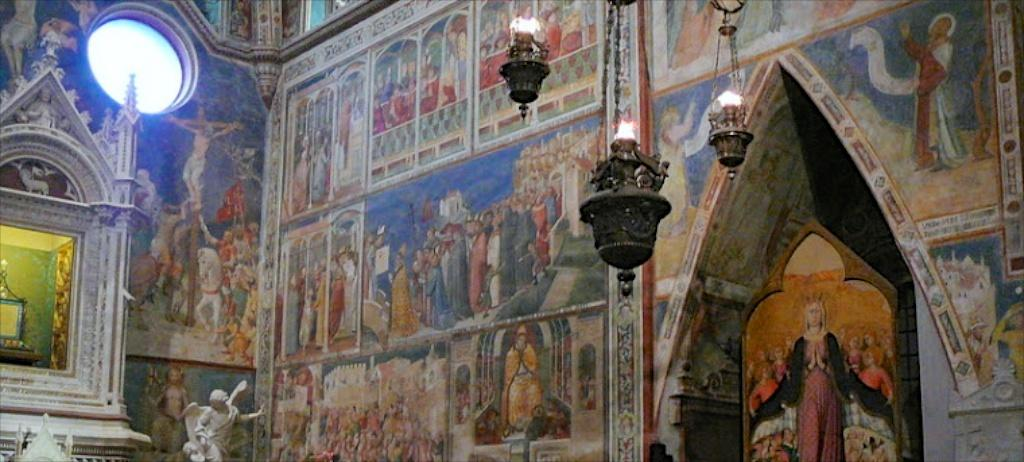What is the main object in the image? There is an object in the image, but its specific nature is not mentioned. Can you describe any other prominent features in the image? Yes, there is a statue and lanterns in the image. Are there any decorative elements visible in the image? Yes, there are paintings on the walls in the image. What else can be seen in the image that is not specified? There are some unspecified objects in the image. How many bears are sitting on the beds in the image? There are no bears or beds present in the image. 